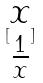<formula> <loc_0><loc_0><loc_500><loc_500>[ \begin{matrix} x \\ \frac { 1 } { x } \end{matrix} ]</formula> 